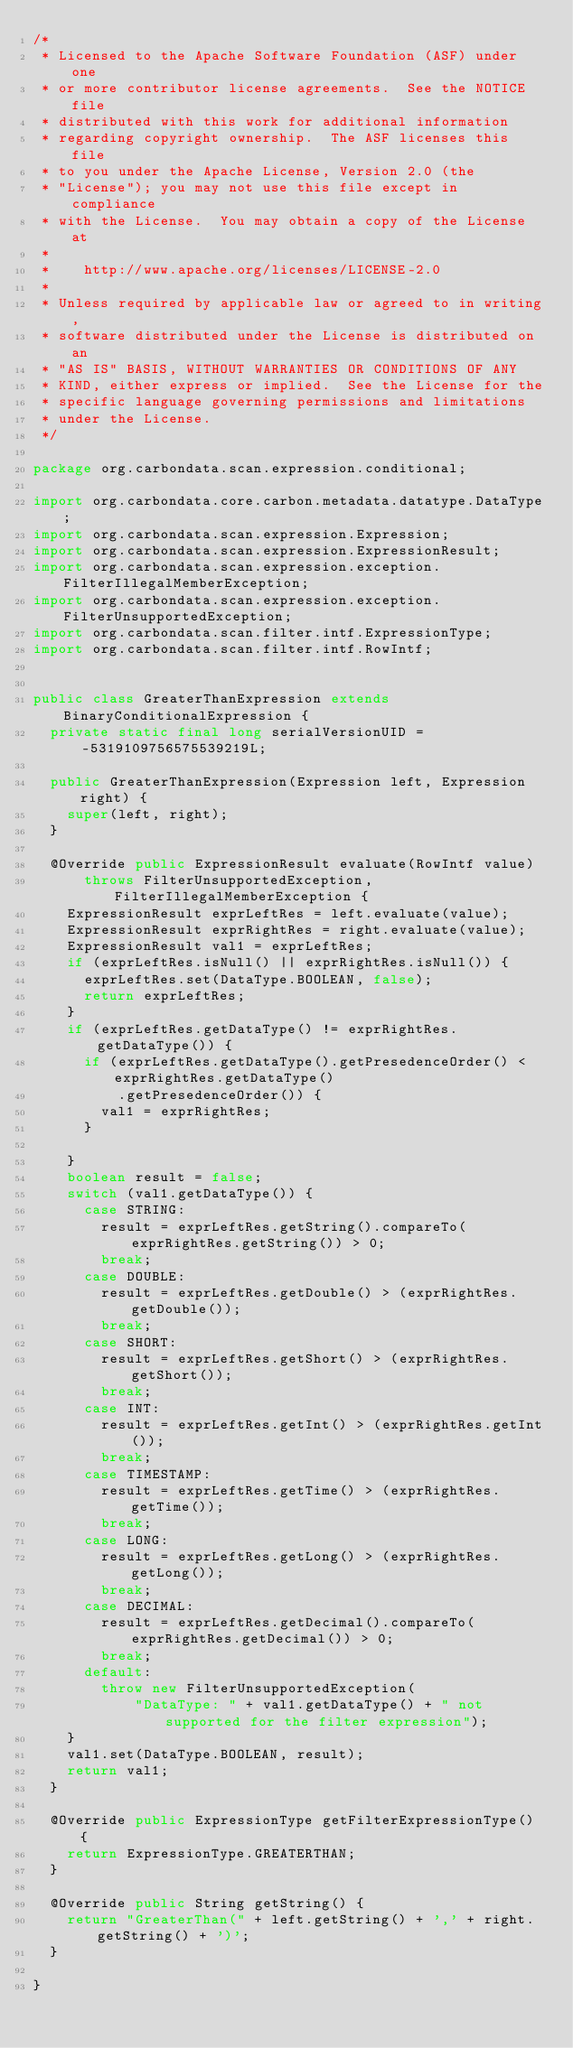<code> <loc_0><loc_0><loc_500><loc_500><_Java_>/*
 * Licensed to the Apache Software Foundation (ASF) under one
 * or more contributor license agreements.  See the NOTICE file
 * distributed with this work for additional information
 * regarding copyright ownership.  The ASF licenses this file
 * to you under the Apache License, Version 2.0 (the
 * "License"); you may not use this file except in compliance
 * with the License.  You may obtain a copy of the License at
 *
 *    http://www.apache.org/licenses/LICENSE-2.0
 *
 * Unless required by applicable law or agreed to in writing,
 * software distributed under the License is distributed on an
 * "AS IS" BASIS, WITHOUT WARRANTIES OR CONDITIONS OF ANY
 * KIND, either express or implied.  See the License for the
 * specific language governing permissions and limitations
 * under the License.
 */

package org.carbondata.scan.expression.conditional;

import org.carbondata.core.carbon.metadata.datatype.DataType;
import org.carbondata.scan.expression.Expression;
import org.carbondata.scan.expression.ExpressionResult;
import org.carbondata.scan.expression.exception.FilterIllegalMemberException;
import org.carbondata.scan.expression.exception.FilterUnsupportedException;
import org.carbondata.scan.filter.intf.ExpressionType;
import org.carbondata.scan.filter.intf.RowIntf;


public class GreaterThanExpression extends BinaryConditionalExpression {
  private static final long serialVersionUID = -5319109756575539219L;

  public GreaterThanExpression(Expression left, Expression right) {
    super(left, right);
  }

  @Override public ExpressionResult evaluate(RowIntf value)
      throws FilterUnsupportedException, FilterIllegalMemberException {
    ExpressionResult exprLeftRes = left.evaluate(value);
    ExpressionResult exprRightRes = right.evaluate(value);
    ExpressionResult val1 = exprLeftRes;
    if (exprLeftRes.isNull() || exprRightRes.isNull()) {
      exprLeftRes.set(DataType.BOOLEAN, false);
      return exprLeftRes;
    }
    if (exprLeftRes.getDataType() != exprRightRes.getDataType()) {
      if (exprLeftRes.getDataType().getPresedenceOrder() < exprRightRes.getDataType()
          .getPresedenceOrder()) {
        val1 = exprRightRes;
      }

    }
    boolean result = false;
    switch (val1.getDataType()) {
      case STRING:
        result = exprLeftRes.getString().compareTo(exprRightRes.getString()) > 0;
        break;
      case DOUBLE:
        result = exprLeftRes.getDouble() > (exprRightRes.getDouble());
        break;
      case SHORT:
        result = exprLeftRes.getShort() > (exprRightRes.getShort());
        break;
      case INT:
        result = exprLeftRes.getInt() > (exprRightRes.getInt());
        break;
      case TIMESTAMP:
        result = exprLeftRes.getTime() > (exprRightRes.getTime());
        break;
      case LONG:
        result = exprLeftRes.getLong() > (exprRightRes.getLong());
        break;
      case DECIMAL:
        result = exprLeftRes.getDecimal().compareTo(exprRightRes.getDecimal()) > 0;
        break;
      default:
        throw new FilterUnsupportedException(
            "DataType: " + val1.getDataType() + " not supported for the filter expression");
    }
    val1.set(DataType.BOOLEAN, result);
    return val1;
  }

  @Override public ExpressionType getFilterExpressionType() {
    return ExpressionType.GREATERTHAN;
  }

  @Override public String getString() {
    return "GreaterThan(" + left.getString() + ',' + right.getString() + ')';
  }

}
</code> 